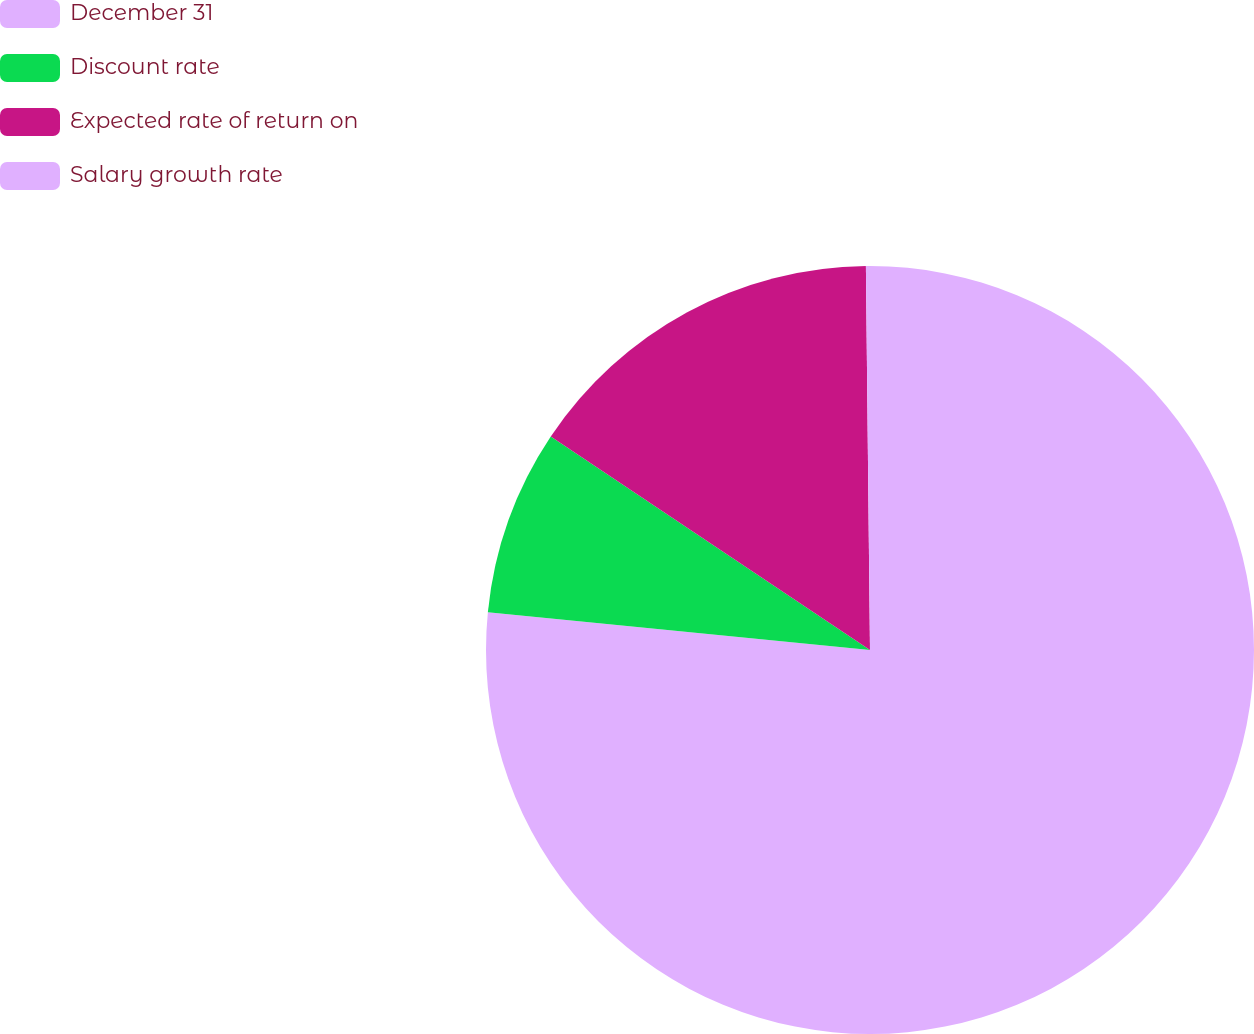<chart> <loc_0><loc_0><loc_500><loc_500><pie_chart><fcel>December 31<fcel>Discount rate<fcel>Expected rate of return on<fcel>Salary growth rate<nl><fcel>76.57%<fcel>7.81%<fcel>15.45%<fcel>0.17%<nl></chart> 